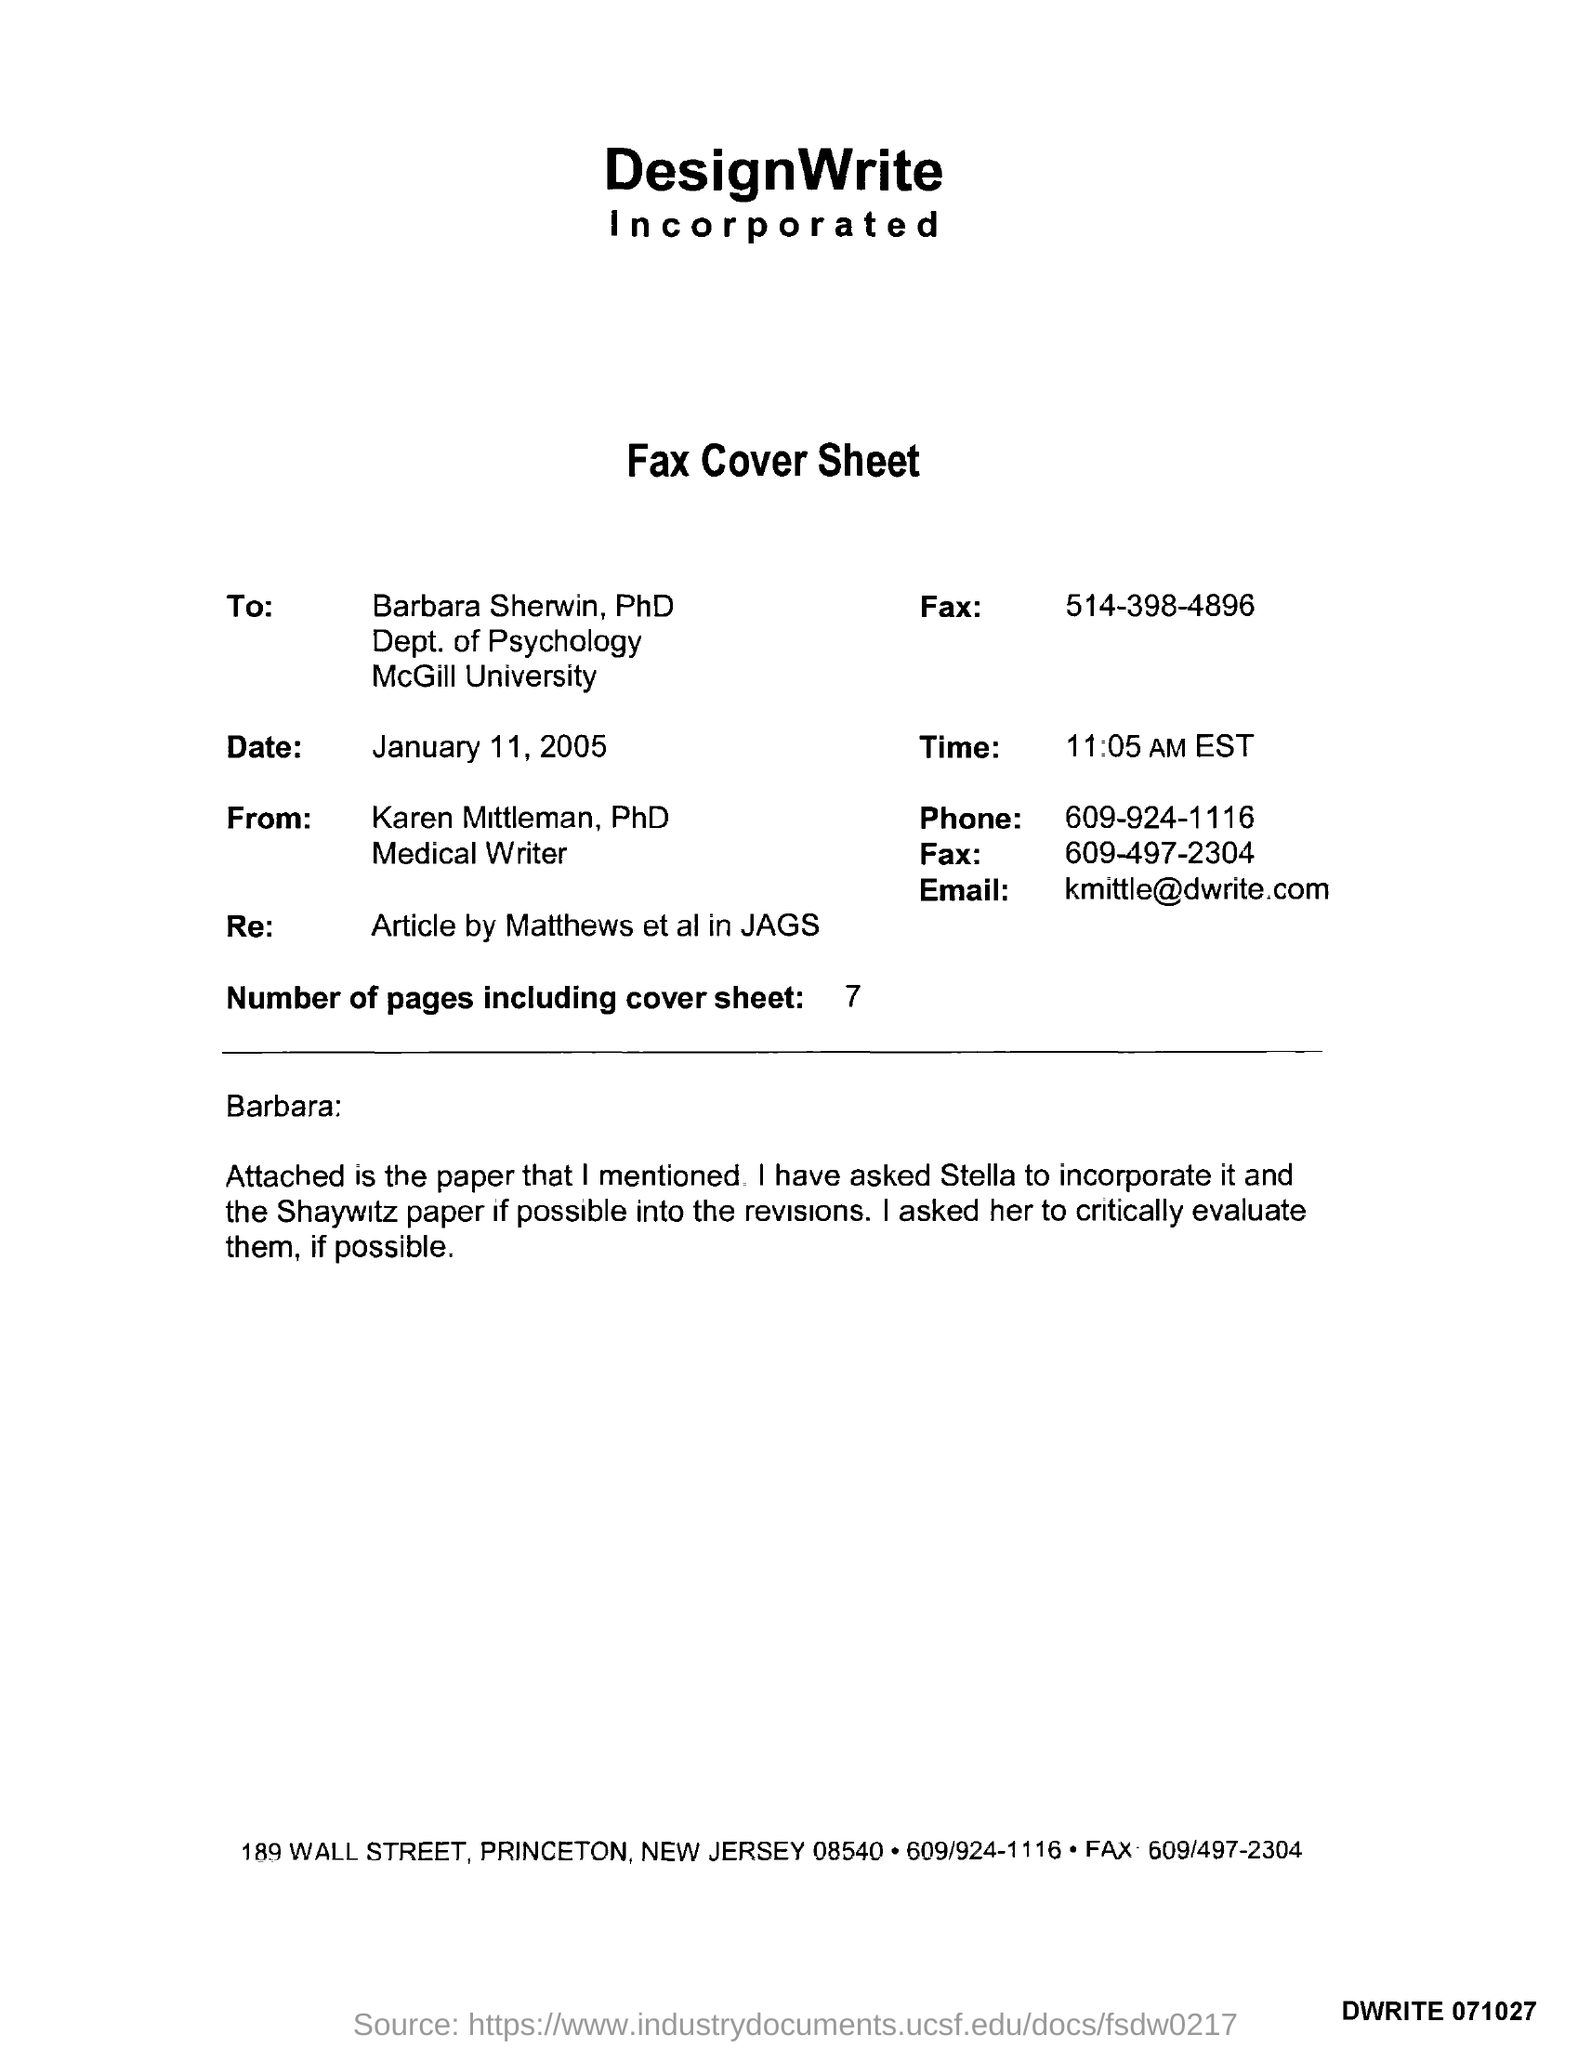Identify some key points in this picture. There are 7 pages in the fax including the cover sheet. The sender of the fax is Karen Mittleman. The fax number of Barbara Sherwin, PhD, is 514-398-4896. Karen Mittleman, PhD, is a medical writer with a designation. Barbara Sherwin, PhD, works at McGill University. 